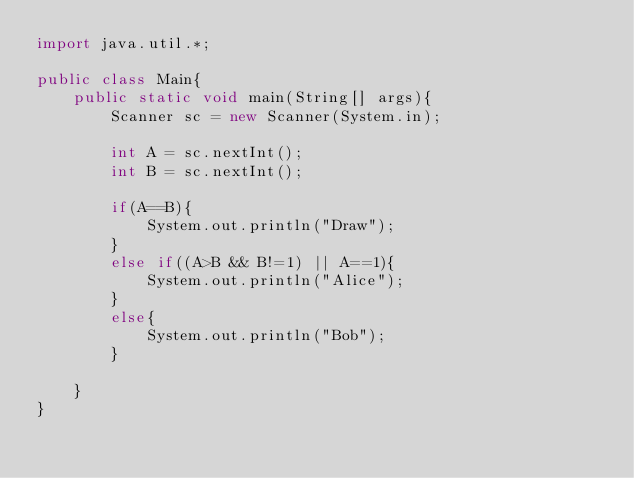Convert code to text. <code><loc_0><loc_0><loc_500><loc_500><_Java_>import java.util.*;

public class Main{
    public static void main(String[] args){
        Scanner sc = new Scanner(System.in);

        int A = sc.nextInt();
        int B = sc.nextInt();

        if(A==B){
            System.out.println("Draw");
        }
        else if((A>B && B!=1) || A==1){
            System.out.println("Alice");
        }
        else{
            System.out.println("Bob");
        }

    }
}</code> 